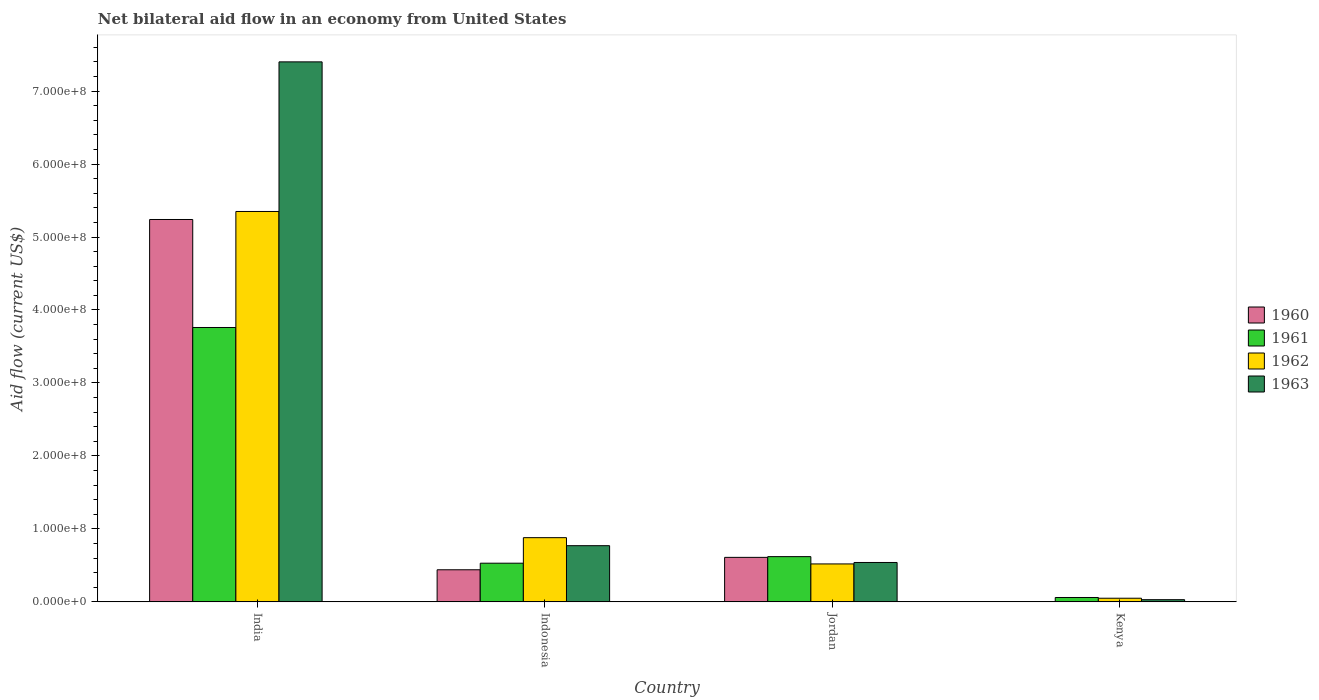How many different coloured bars are there?
Your response must be concise. 4. Are the number of bars per tick equal to the number of legend labels?
Offer a terse response. Yes. Are the number of bars on each tick of the X-axis equal?
Make the answer very short. Yes. How many bars are there on the 1st tick from the left?
Provide a short and direct response. 4. How many bars are there on the 2nd tick from the right?
Ensure brevity in your answer.  4. What is the label of the 3rd group of bars from the left?
Ensure brevity in your answer.  Jordan. What is the net bilateral aid flow in 1962 in India?
Keep it short and to the point. 5.35e+08. Across all countries, what is the maximum net bilateral aid flow in 1961?
Your answer should be very brief. 3.76e+08. Across all countries, what is the minimum net bilateral aid flow in 1960?
Keep it short and to the point. 4.80e+05. In which country was the net bilateral aid flow in 1960 minimum?
Your answer should be very brief. Kenya. What is the total net bilateral aid flow in 1963 in the graph?
Offer a very short reply. 8.74e+08. What is the difference between the net bilateral aid flow in 1960 in India and that in Kenya?
Your answer should be very brief. 5.24e+08. What is the difference between the net bilateral aid flow in 1963 in Kenya and the net bilateral aid flow in 1961 in Indonesia?
Your response must be concise. -5.00e+07. What is the average net bilateral aid flow in 1962 per country?
Your response must be concise. 1.70e+08. What is the difference between the net bilateral aid flow of/in 1961 and net bilateral aid flow of/in 1960 in India?
Make the answer very short. -1.48e+08. In how many countries, is the net bilateral aid flow in 1960 greater than 700000000 US$?
Provide a succinct answer. 0. What is the ratio of the net bilateral aid flow in 1962 in India to that in Indonesia?
Offer a very short reply. 6.08. Is the difference between the net bilateral aid flow in 1961 in India and Kenya greater than the difference between the net bilateral aid flow in 1960 in India and Kenya?
Provide a succinct answer. No. What is the difference between the highest and the second highest net bilateral aid flow in 1962?
Your answer should be very brief. 4.47e+08. What is the difference between the highest and the lowest net bilateral aid flow in 1962?
Offer a very short reply. 5.30e+08. What does the 2nd bar from the left in Kenya represents?
Keep it short and to the point. 1961. What does the 2nd bar from the right in Jordan represents?
Provide a succinct answer. 1962. How many bars are there?
Give a very brief answer. 16. How many countries are there in the graph?
Your response must be concise. 4. How are the legend labels stacked?
Offer a terse response. Vertical. What is the title of the graph?
Provide a short and direct response. Net bilateral aid flow in an economy from United States. Does "2001" appear as one of the legend labels in the graph?
Your answer should be very brief. No. What is the label or title of the X-axis?
Your answer should be very brief. Country. What is the Aid flow (current US$) of 1960 in India?
Offer a very short reply. 5.24e+08. What is the Aid flow (current US$) of 1961 in India?
Your answer should be compact. 3.76e+08. What is the Aid flow (current US$) of 1962 in India?
Offer a very short reply. 5.35e+08. What is the Aid flow (current US$) of 1963 in India?
Provide a succinct answer. 7.40e+08. What is the Aid flow (current US$) in 1960 in Indonesia?
Provide a short and direct response. 4.40e+07. What is the Aid flow (current US$) of 1961 in Indonesia?
Offer a very short reply. 5.30e+07. What is the Aid flow (current US$) in 1962 in Indonesia?
Keep it short and to the point. 8.80e+07. What is the Aid flow (current US$) of 1963 in Indonesia?
Make the answer very short. 7.70e+07. What is the Aid flow (current US$) in 1960 in Jordan?
Provide a succinct answer. 6.10e+07. What is the Aid flow (current US$) in 1961 in Jordan?
Your answer should be very brief. 6.20e+07. What is the Aid flow (current US$) of 1962 in Jordan?
Provide a short and direct response. 5.20e+07. What is the Aid flow (current US$) in 1963 in Jordan?
Give a very brief answer. 5.40e+07. Across all countries, what is the maximum Aid flow (current US$) in 1960?
Offer a terse response. 5.24e+08. Across all countries, what is the maximum Aid flow (current US$) in 1961?
Provide a short and direct response. 3.76e+08. Across all countries, what is the maximum Aid flow (current US$) in 1962?
Keep it short and to the point. 5.35e+08. Across all countries, what is the maximum Aid flow (current US$) in 1963?
Offer a terse response. 7.40e+08. Across all countries, what is the minimum Aid flow (current US$) of 1960?
Make the answer very short. 4.80e+05. Across all countries, what is the minimum Aid flow (current US$) in 1961?
Ensure brevity in your answer.  6.00e+06. Across all countries, what is the minimum Aid flow (current US$) of 1962?
Make the answer very short. 5.00e+06. Across all countries, what is the minimum Aid flow (current US$) of 1963?
Make the answer very short. 3.00e+06. What is the total Aid flow (current US$) in 1960 in the graph?
Offer a terse response. 6.29e+08. What is the total Aid flow (current US$) of 1961 in the graph?
Provide a short and direct response. 4.97e+08. What is the total Aid flow (current US$) in 1962 in the graph?
Offer a very short reply. 6.80e+08. What is the total Aid flow (current US$) of 1963 in the graph?
Offer a terse response. 8.74e+08. What is the difference between the Aid flow (current US$) of 1960 in India and that in Indonesia?
Provide a succinct answer. 4.80e+08. What is the difference between the Aid flow (current US$) in 1961 in India and that in Indonesia?
Your answer should be very brief. 3.23e+08. What is the difference between the Aid flow (current US$) in 1962 in India and that in Indonesia?
Provide a short and direct response. 4.47e+08. What is the difference between the Aid flow (current US$) of 1963 in India and that in Indonesia?
Make the answer very short. 6.63e+08. What is the difference between the Aid flow (current US$) of 1960 in India and that in Jordan?
Keep it short and to the point. 4.63e+08. What is the difference between the Aid flow (current US$) of 1961 in India and that in Jordan?
Your answer should be very brief. 3.14e+08. What is the difference between the Aid flow (current US$) in 1962 in India and that in Jordan?
Your response must be concise. 4.83e+08. What is the difference between the Aid flow (current US$) in 1963 in India and that in Jordan?
Offer a very short reply. 6.86e+08. What is the difference between the Aid flow (current US$) in 1960 in India and that in Kenya?
Keep it short and to the point. 5.24e+08. What is the difference between the Aid flow (current US$) in 1961 in India and that in Kenya?
Your answer should be compact. 3.70e+08. What is the difference between the Aid flow (current US$) of 1962 in India and that in Kenya?
Offer a very short reply. 5.30e+08. What is the difference between the Aid flow (current US$) in 1963 in India and that in Kenya?
Offer a terse response. 7.37e+08. What is the difference between the Aid flow (current US$) in 1960 in Indonesia and that in Jordan?
Keep it short and to the point. -1.70e+07. What is the difference between the Aid flow (current US$) in 1961 in Indonesia and that in Jordan?
Your answer should be compact. -9.00e+06. What is the difference between the Aid flow (current US$) of 1962 in Indonesia and that in Jordan?
Your answer should be very brief. 3.60e+07. What is the difference between the Aid flow (current US$) in 1963 in Indonesia and that in Jordan?
Offer a terse response. 2.30e+07. What is the difference between the Aid flow (current US$) of 1960 in Indonesia and that in Kenya?
Provide a succinct answer. 4.35e+07. What is the difference between the Aid flow (current US$) of 1961 in Indonesia and that in Kenya?
Provide a succinct answer. 4.70e+07. What is the difference between the Aid flow (current US$) of 1962 in Indonesia and that in Kenya?
Ensure brevity in your answer.  8.30e+07. What is the difference between the Aid flow (current US$) in 1963 in Indonesia and that in Kenya?
Your answer should be compact. 7.40e+07. What is the difference between the Aid flow (current US$) in 1960 in Jordan and that in Kenya?
Keep it short and to the point. 6.05e+07. What is the difference between the Aid flow (current US$) of 1961 in Jordan and that in Kenya?
Provide a short and direct response. 5.60e+07. What is the difference between the Aid flow (current US$) of 1962 in Jordan and that in Kenya?
Provide a succinct answer. 4.70e+07. What is the difference between the Aid flow (current US$) in 1963 in Jordan and that in Kenya?
Your answer should be very brief. 5.10e+07. What is the difference between the Aid flow (current US$) of 1960 in India and the Aid flow (current US$) of 1961 in Indonesia?
Ensure brevity in your answer.  4.71e+08. What is the difference between the Aid flow (current US$) of 1960 in India and the Aid flow (current US$) of 1962 in Indonesia?
Give a very brief answer. 4.36e+08. What is the difference between the Aid flow (current US$) of 1960 in India and the Aid flow (current US$) of 1963 in Indonesia?
Make the answer very short. 4.47e+08. What is the difference between the Aid flow (current US$) in 1961 in India and the Aid flow (current US$) in 1962 in Indonesia?
Keep it short and to the point. 2.88e+08. What is the difference between the Aid flow (current US$) in 1961 in India and the Aid flow (current US$) in 1963 in Indonesia?
Ensure brevity in your answer.  2.99e+08. What is the difference between the Aid flow (current US$) in 1962 in India and the Aid flow (current US$) in 1963 in Indonesia?
Your answer should be compact. 4.58e+08. What is the difference between the Aid flow (current US$) in 1960 in India and the Aid flow (current US$) in 1961 in Jordan?
Your answer should be very brief. 4.62e+08. What is the difference between the Aid flow (current US$) in 1960 in India and the Aid flow (current US$) in 1962 in Jordan?
Your answer should be very brief. 4.72e+08. What is the difference between the Aid flow (current US$) of 1960 in India and the Aid flow (current US$) of 1963 in Jordan?
Your response must be concise. 4.70e+08. What is the difference between the Aid flow (current US$) in 1961 in India and the Aid flow (current US$) in 1962 in Jordan?
Ensure brevity in your answer.  3.24e+08. What is the difference between the Aid flow (current US$) of 1961 in India and the Aid flow (current US$) of 1963 in Jordan?
Provide a short and direct response. 3.22e+08. What is the difference between the Aid flow (current US$) of 1962 in India and the Aid flow (current US$) of 1963 in Jordan?
Make the answer very short. 4.81e+08. What is the difference between the Aid flow (current US$) of 1960 in India and the Aid flow (current US$) of 1961 in Kenya?
Provide a succinct answer. 5.18e+08. What is the difference between the Aid flow (current US$) of 1960 in India and the Aid flow (current US$) of 1962 in Kenya?
Ensure brevity in your answer.  5.19e+08. What is the difference between the Aid flow (current US$) of 1960 in India and the Aid flow (current US$) of 1963 in Kenya?
Your answer should be very brief. 5.21e+08. What is the difference between the Aid flow (current US$) of 1961 in India and the Aid flow (current US$) of 1962 in Kenya?
Ensure brevity in your answer.  3.71e+08. What is the difference between the Aid flow (current US$) of 1961 in India and the Aid flow (current US$) of 1963 in Kenya?
Offer a very short reply. 3.73e+08. What is the difference between the Aid flow (current US$) in 1962 in India and the Aid flow (current US$) in 1963 in Kenya?
Your answer should be very brief. 5.32e+08. What is the difference between the Aid flow (current US$) of 1960 in Indonesia and the Aid flow (current US$) of 1961 in Jordan?
Your response must be concise. -1.80e+07. What is the difference between the Aid flow (current US$) in 1960 in Indonesia and the Aid flow (current US$) in 1962 in Jordan?
Offer a very short reply. -8.00e+06. What is the difference between the Aid flow (current US$) of 1960 in Indonesia and the Aid flow (current US$) of 1963 in Jordan?
Provide a short and direct response. -1.00e+07. What is the difference between the Aid flow (current US$) in 1962 in Indonesia and the Aid flow (current US$) in 1963 in Jordan?
Offer a terse response. 3.40e+07. What is the difference between the Aid flow (current US$) in 1960 in Indonesia and the Aid flow (current US$) in 1961 in Kenya?
Offer a terse response. 3.80e+07. What is the difference between the Aid flow (current US$) in 1960 in Indonesia and the Aid flow (current US$) in 1962 in Kenya?
Your answer should be compact. 3.90e+07. What is the difference between the Aid flow (current US$) of 1960 in Indonesia and the Aid flow (current US$) of 1963 in Kenya?
Your answer should be compact. 4.10e+07. What is the difference between the Aid flow (current US$) in 1961 in Indonesia and the Aid flow (current US$) in 1962 in Kenya?
Provide a succinct answer. 4.80e+07. What is the difference between the Aid flow (current US$) of 1961 in Indonesia and the Aid flow (current US$) of 1963 in Kenya?
Keep it short and to the point. 5.00e+07. What is the difference between the Aid flow (current US$) of 1962 in Indonesia and the Aid flow (current US$) of 1963 in Kenya?
Your answer should be very brief. 8.50e+07. What is the difference between the Aid flow (current US$) in 1960 in Jordan and the Aid flow (current US$) in 1961 in Kenya?
Provide a succinct answer. 5.50e+07. What is the difference between the Aid flow (current US$) of 1960 in Jordan and the Aid flow (current US$) of 1962 in Kenya?
Make the answer very short. 5.60e+07. What is the difference between the Aid flow (current US$) of 1960 in Jordan and the Aid flow (current US$) of 1963 in Kenya?
Provide a succinct answer. 5.80e+07. What is the difference between the Aid flow (current US$) in 1961 in Jordan and the Aid flow (current US$) in 1962 in Kenya?
Give a very brief answer. 5.70e+07. What is the difference between the Aid flow (current US$) in 1961 in Jordan and the Aid flow (current US$) in 1963 in Kenya?
Your answer should be compact. 5.90e+07. What is the difference between the Aid flow (current US$) in 1962 in Jordan and the Aid flow (current US$) in 1963 in Kenya?
Your answer should be compact. 4.90e+07. What is the average Aid flow (current US$) in 1960 per country?
Your answer should be compact. 1.57e+08. What is the average Aid flow (current US$) of 1961 per country?
Provide a succinct answer. 1.24e+08. What is the average Aid flow (current US$) in 1962 per country?
Your response must be concise. 1.70e+08. What is the average Aid flow (current US$) of 1963 per country?
Provide a short and direct response. 2.18e+08. What is the difference between the Aid flow (current US$) in 1960 and Aid flow (current US$) in 1961 in India?
Your response must be concise. 1.48e+08. What is the difference between the Aid flow (current US$) in 1960 and Aid flow (current US$) in 1962 in India?
Your response must be concise. -1.10e+07. What is the difference between the Aid flow (current US$) of 1960 and Aid flow (current US$) of 1963 in India?
Offer a very short reply. -2.16e+08. What is the difference between the Aid flow (current US$) of 1961 and Aid flow (current US$) of 1962 in India?
Provide a succinct answer. -1.59e+08. What is the difference between the Aid flow (current US$) of 1961 and Aid flow (current US$) of 1963 in India?
Keep it short and to the point. -3.64e+08. What is the difference between the Aid flow (current US$) in 1962 and Aid flow (current US$) in 1963 in India?
Offer a terse response. -2.05e+08. What is the difference between the Aid flow (current US$) in 1960 and Aid flow (current US$) in 1961 in Indonesia?
Provide a short and direct response. -9.00e+06. What is the difference between the Aid flow (current US$) in 1960 and Aid flow (current US$) in 1962 in Indonesia?
Keep it short and to the point. -4.40e+07. What is the difference between the Aid flow (current US$) of 1960 and Aid flow (current US$) of 1963 in Indonesia?
Keep it short and to the point. -3.30e+07. What is the difference between the Aid flow (current US$) in 1961 and Aid flow (current US$) in 1962 in Indonesia?
Keep it short and to the point. -3.50e+07. What is the difference between the Aid flow (current US$) in 1961 and Aid flow (current US$) in 1963 in Indonesia?
Offer a very short reply. -2.40e+07. What is the difference between the Aid flow (current US$) of 1962 and Aid flow (current US$) of 1963 in Indonesia?
Your answer should be very brief. 1.10e+07. What is the difference between the Aid flow (current US$) in 1960 and Aid flow (current US$) in 1961 in Jordan?
Offer a terse response. -1.00e+06. What is the difference between the Aid flow (current US$) of 1960 and Aid flow (current US$) of 1962 in Jordan?
Your answer should be very brief. 9.00e+06. What is the difference between the Aid flow (current US$) in 1961 and Aid flow (current US$) in 1962 in Jordan?
Provide a succinct answer. 1.00e+07. What is the difference between the Aid flow (current US$) of 1960 and Aid flow (current US$) of 1961 in Kenya?
Your answer should be very brief. -5.52e+06. What is the difference between the Aid flow (current US$) in 1960 and Aid flow (current US$) in 1962 in Kenya?
Provide a short and direct response. -4.52e+06. What is the difference between the Aid flow (current US$) of 1960 and Aid flow (current US$) of 1963 in Kenya?
Your answer should be very brief. -2.52e+06. What is the difference between the Aid flow (current US$) in 1962 and Aid flow (current US$) in 1963 in Kenya?
Provide a succinct answer. 2.00e+06. What is the ratio of the Aid flow (current US$) in 1960 in India to that in Indonesia?
Your response must be concise. 11.91. What is the ratio of the Aid flow (current US$) in 1961 in India to that in Indonesia?
Provide a succinct answer. 7.09. What is the ratio of the Aid flow (current US$) of 1962 in India to that in Indonesia?
Offer a very short reply. 6.08. What is the ratio of the Aid flow (current US$) in 1963 in India to that in Indonesia?
Offer a very short reply. 9.61. What is the ratio of the Aid flow (current US$) of 1960 in India to that in Jordan?
Provide a short and direct response. 8.59. What is the ratio of the Aid flow (current US$) of 1961 in India to that in Jordan?
Make the answer very short. 6.06. What is the ratio of the Aid flow (current US$) of 1962 in India to that in Jordan?
Keep it short and to the point. 10.29. What is the ratio of the Aid flow (current US$) of 1963 in India to that in Jordan?
Provide a short and direct response. 13.7. What is the ratio of the Aid flow (current US$) in 1960 in India to that in Kenya?
Offer a very short reply. 1091.67. What is the ratio of the Aid flow (current US$) in 1961 in India to that in Kenya?
Offer a very short reply. 62.67. What is the ratio of the Aid flow (current US$) of 1962 in India to that in Kenya?
Offer a terse response. 107. What is the ratio of the Aid flow (current US$) in 1963 in India to that in Kenya?
Your answer should be very brief. 246.67. What is the ratio of the Aid flow (current US$) of 1960 in Indonesia to that in Jordan?
Offer a terse response. 0.72. What is the ratio of the Aid flow (current US$) in 1961 in Indonesia to that in Jordan?
Offer a terse response. 0.85. What is the ratio of the Aid flow (current US$) in 1962 in Indonesia to that in Jordan?
Ensure brevity in your answer.  1.69. What is the ratio of the Aid flow (current US$) in 1963 in Indonesia to that in Jordan?
Offer a very short reply. 1.43. What is the ratio of the Aid flow (current US$) of 1960 in Indonesia to that in Kenya?
Your answer should be very brief. 91.67. What is the ratio of the Aid flow (current US$) of 1961 in Indonesia to that in Kenya?
Offer a terse response. 8.83. What is the ratio of the Aid flow (current US$) of 1963 in Indonesia to that in Kenya?
Give a very brief answer. 25.67. What is the ratio of the Aid flow (current US$) in 1960 in Jordan to that in Kenya?
Ensure brevity in your answer.  127.08. What is the ratio of the Aid flow (current US$) of 1961 in Jordan to that in Kenya?
Offer a very short reply. 10.33. What is the ratio of the Aid flow (current US$) in 1962 in Jordan to that in Kenya?
Offer a very short reply. 10.4. What is the ratio of the Aid flow (current US$) of 1963 in Jordan to that in Kenya?
Your response must be concise. 18. What is the difference between the highest and the second highest Aid flow (current US$) in 1960?
Your response must be concise. 4.63e+08. What is the difference between the highest and the second highest Aid flow (current US$) in 1961?
Keep it short and to the point. 3.14e+08. What is the difference between the highest and the second highest Aid flow (current US$) in 1962?
Make the answer very short. 4.47e+08. What is the difference between the highest and the second highest Aid flow (current US$) in 1963?
Your answer should be very brief. 6.63e+08. What is the difference between the highest and the lowest Aid flow (current US$) of 1960?
Offer a terse response. 5.24e+08. What is the difference between the highest and the lowest Aid flow (current US$) of 1961?
Keep it short and to the point. 3.70e+08. What is the difference between the highest and the lowest Aid flow (current US$) of 1962?
Your answer should be compact. 5.30e+08. What is the difference between the highest and the lowest Aid flow (current US$) in 1963?
Make the answer very short. 7.37e+08. 